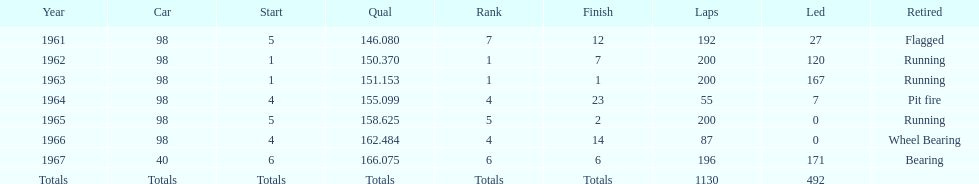What car achieved the highest qual? 40. 